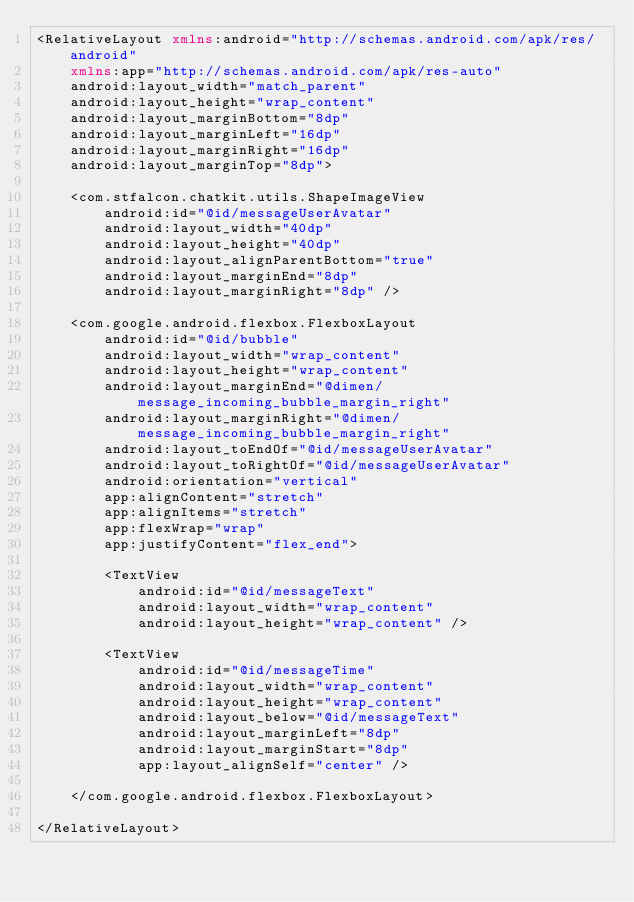<code> <loc_0><loc_0><loc_500><loc_500><_XML_><RelativeLayout xmlns:android="http://schemas.android.com/apk/res/android"
    xmlns:app="http://schemas.android.com/apk/res-auto"
    android:layout_width="match_parent"
    android:layout_height="wrap_content"
    android:layout_marginBottom="8dp"
    android:layout_marginLeft="16dp"
    android:layout_marginRight="16dp"
    android:layout_marginTop="8dp">

    <com.stfalcon.chatkit.utils.ShapeImageView
        android:id="@id/messageUserAvatar"
        android:layout_width="40dp"
        android:layout_height="40dp"
        android:layout_alignParentBottom="true"
        android:layout_marginEnd="8dp"
        android:layout_marginRight="8dp" />

    <com.google.android.flexbox.FlexboxLayout
        android:id="@id/bubble"
        android:layout_width="wrap_content"
        android:layout_height="wrap_content"
        android:layout_marginEnd="@dimen/message_incoming_bubble_margin_right"
        android:layout_marginRight="@dimen/message_incoming_bubble_margin_right"
        android:layout_toEndOf="@id/messageUserAvatar"
        android:layout_toRightOf="@id/messageUserAvatar"
        android:orientation="vertical"
        app:alignContent="stretch"
        app:alignItems="stretch"
        app:flexWrap="wrap"
        app:justifyContent="flex_end">

        <TextView
            android:id="@id/messageText"
            android:layout_width="wrap_content"
            android:layout_height="wrap_content" />

        <TextView
            android:id="@id/messageTime"
            android:layout_width="wrap_content"
            android:layout_height="wrap_content"
            android:layout_below="@id/messageText"
            android:layout_marginLeft="8dp"
            android:layout_marginStart="8dp"
            app:layout_alignSelf="center" />

    </com.google.android.flexbox.FlexboxLayout>

</RelativeLayout></code> 